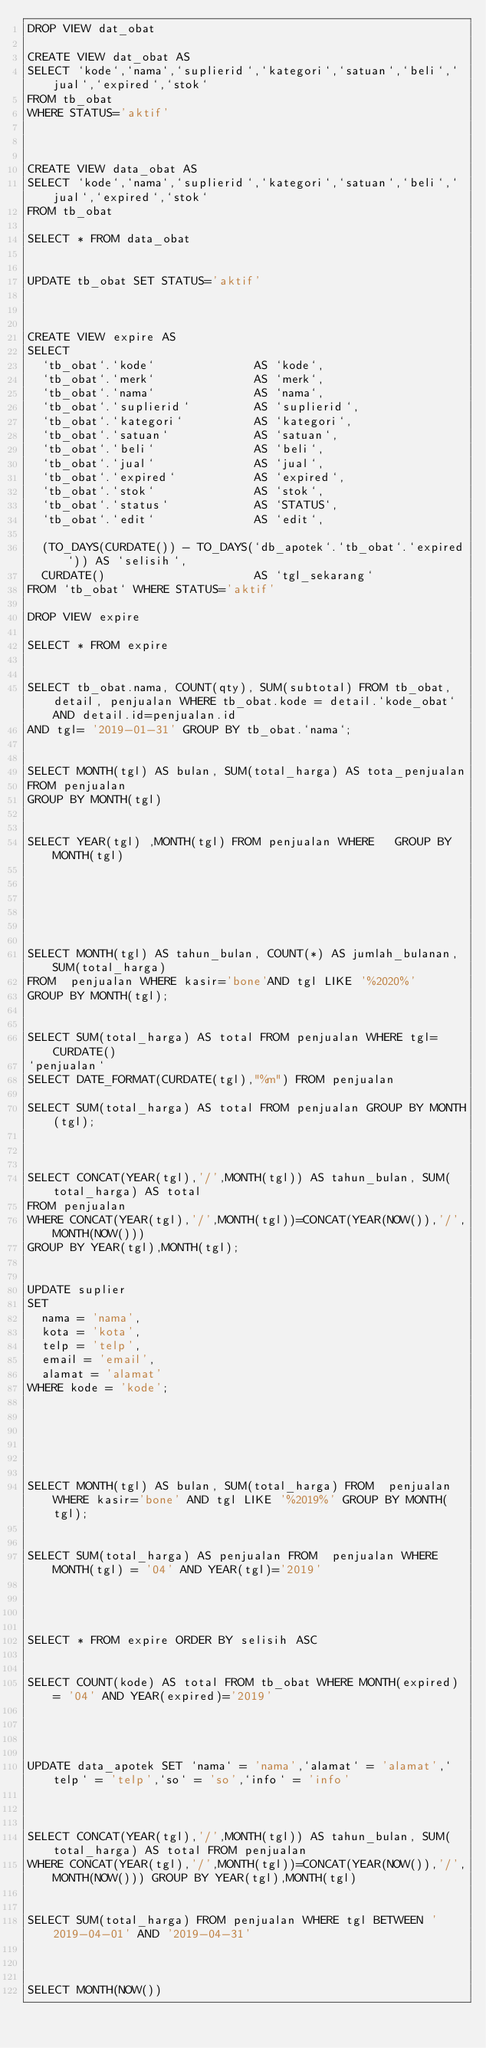Convert code to text. <code><loc_0><loc_0><loc_500><loc_500><_SQL_>DROP VIEW dat_obat

CREATE VIEW dat_obat AS
SELECT `kode`,`nama`,`suplierid`,`kategori`,`satuan`,`beli`,`jual`,`expired`,`stok` 
FROM tb_obat
WHERE STATUS='aktif'



CREATE VIEW data_obat AS
SELECT `kode`,`nama`,`suplierid`,`kategori`,`satuan`,`beli`,`jual`,`expired`,`stok` 
FROM tb_obat

SELECT * FROM data_obat


UPDATE tb_obat SET STATUS='aktif'



CREATE VIEW expire AS
SELECT
  `tb_obat`.`kode`              AS `kode`,
  `tb_obat`.`merk`              AS `merk`,
  `tb_obat`.`nama`              AS `nama`,
  `tb_obat`.`suplierid`         AS `suplierid`,
  `tb_obat`.`kategori`          AS `kategori`,
  `tb_obat`.`satuan`            AS `satuan`,
  `tb_obat`.`beli`              AS `beli`,
  `tb_obat`.`jual`              AS `jual`,
  `tb_obat`.`expired`           AS `expired`,
  `tb_obat`.`stok`              AS `stok`,
  `tb_obat`.`status`            AS `STATUS`,
  `tb_obat`.`edit`              AS `edit`,
  
  (TO_DAYS(CURDATE()) - TO_DAYS(`db_apotek`.`tb_obat`.`expired`)) AS `selisih`,
  CURDATE()                     AS `tgl_sekarang`
FROM `tb_obat` WHERE STATUS='aktif'

DROP VIEW expire

SELECT * FROM expire


SELECT tb_obat.nama, COUNT(qty), SUM(subtotal) FROM tb_obat, detail, penjualan WHERE tb_obat.kode = detail.`kode_obat` AND detail.id=penjualan.id 
AND tgl= '2019-01-31' GROUP BY tb_obat.`nama`;


SELECT MONTH(tgl) AS bulan, SUM(total_harga) AS tota_penjualan
FROM penjualan
GROUP BY MONTH(tgl)


SELECT YEAR(tgl) ,MONTH(tgl) FROM penjualan WHERE   GROUP BY MONTH(tgl)






SELECT MONTH(tgl) AS tahun_bulan, COUNT(*) AS jumlah_bulanan, SUM(total_harga)
FROM  penjualan WHERE kasir='bone'AND tgl LIKE '%2020%'
GROUP BY MONTH(tgl);


SELECT SUM(total_harga) AS total FROM penjualan WHERE tgl=CURDATE()
`penjualan`
SELECT DATE_FORMAT(CURDATE(tgl),"%m") FROM penjualan

SELECT SUM(total_harga) AS total FROM penjualan GROUP BY MONTH(tgl);



SELECT CONCAT(YEAR(tgl),'/',MONTH(tgl)) AS tahun_bulan, SUM(total_harga) AS total
FROM penjualan
WHERE CONCAT(YEAR(tgl),'/',MONTH(tgl))=CONCAT(YEAR(NOW()),'/',MONTH(NOW()))
GROUP BY YEAR(tgl),MONTH(tgl);


UPDATE suplier
SET 
  nama = 'nama',
  kota = 'kota',
  telp = 'telp',
  email = 'email',
  alamat = 'alamat'
WHERE kode = 'kode';






SELECT MONTH(tgl) AS bulan, SUM(total_harga) FROM  penjualan WHERE kasir='bone' AND tgl LIKE '%2019%' GROUP BY MONTH(tgl);


SELECT SUM(total_harga) AS penjualan FROM  penjualan WHERE MONTH(tgl) = '04' AND YEAR(tgl)='2019'




SELECT * FROM expire ORDER BY selisih ASC


SELECT COUNT(kode) AS total FROM tb_obat WHERE MONTH(expired) = '04' AND YEAR(expired)='2019'




UPDATE data_apotek SET `nama` = 'nama',`alamat` = 'alamat',`telp` = 'telp',`so` = 'so',`info` = 'info'



SELECT CONCAT(YEAR(tgl),'/',MONTH(tgl)) AS tahun_bulan, SUM(total_harga) AS total FROM penjualan 
WHERE CONCAT(YEAR(tgl),'/',MONTH(tgl))=CONCAT(YEAR(NOW()),'/',MONTH(NOW())) GROUP BY YEAR(tgl),MONTH(tgl)


SELECT SUM(total_harga) FROM penjualan WHERE tgl BETWEEN '2019-04-01' AND '2019-04-31'



SELECT MONTH(NOW())</code> 